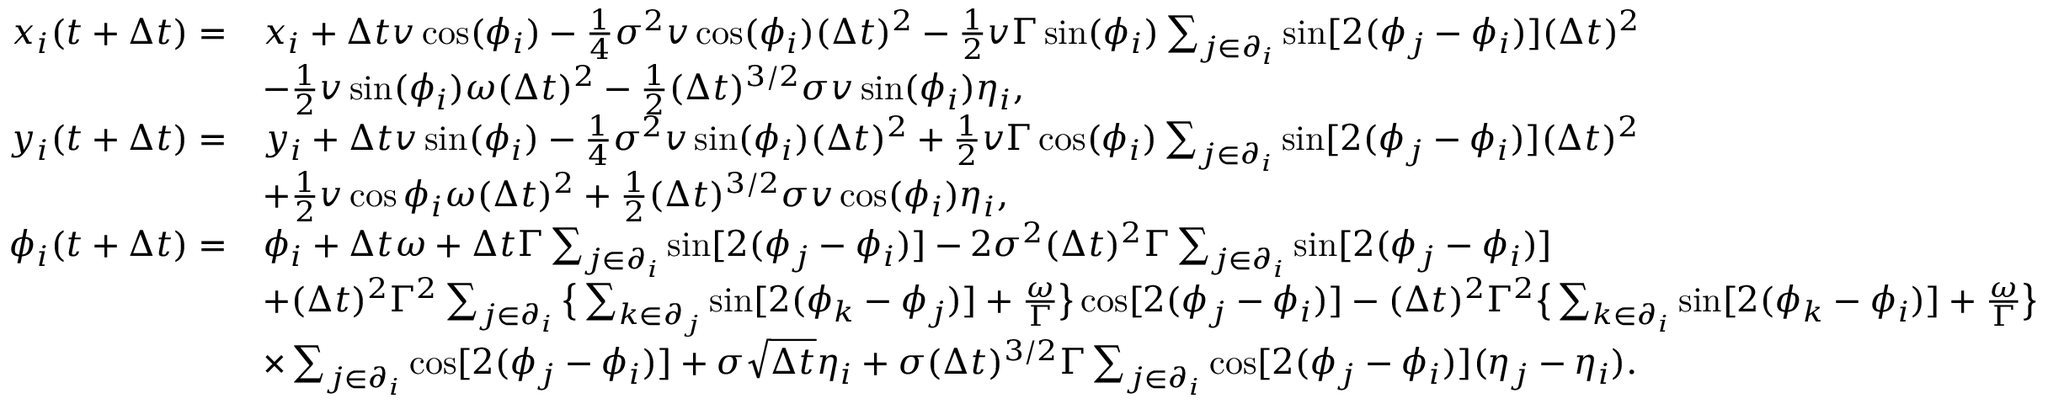<formula> <loc_0><loc_0><loc_500><loc_500>\begin{array} { r l } { x _ { i } ( t + \Delta t ) = } & { x _ { i } + \Delta t v \cos ( \phi _ { i } ) - \frac { 1 } { 4 } \sigma ^ { 2 } v \cos ( \phi _ { i } ) ( \Delta t ) ^ { 2 } - \frac { 1 } { 2 } v \Gamma \sin ( \phi _ { i } ) \sum _ { j \in \partial _ { i } } \sin [ 2 ( \phi _ { j } - \phi _ { i } ) ] ( \Delta t ) ^ { 2 } } \\ & { - \frac { 1 } { 2 } v \sin ( \phi _ { i } ) \omega ( \Delta t ) ^ { 2 } - \frac { 1 } { 2 } ( \Delta t ) ^ { 3 / 2 } \sigma v \sin ( \phi _ { i } ) \eta _ { i } , } \\ { y _ { i } ( t + \Delta t ) = } & { y _ { i } + \Delta t v \sin ( \phi _ { i } ) - \frac { 1 } { 4 } \sigma ^ { 2 } v \sin ( \phi _ { i } ) ( \Delta t ) ^ { 2 } + \frac { 1 } { 2 } v \Gamma \cos ( \phi _ { i } ) \sum _ { j \in \partial _ { i } } \sin [ 2 ( \phi _ { j } - \phi _ { i } ) ] ( \Delta t ) ^ { 2 } } \\ & { + \frac { 1 } { 2 } v \cos { \phi _ { i } } \omega ( \Delta t ) ^ { 2 } + \frac { 1 } { 2 } ( \Delta t ) ^ { 3 / 2 } \sigma v \cos ( \phi _ { i } ) \eta _ { i } , } \\ { \phi _ { i } ( t + \Delta t ) = } & { \phi _ { i } + \Delta t \omega + \Delta t \Gamma \sum _ { j \in \partial _ { i } } \sin [ 2 ( \phi _ { j } - \phi _ { i } ) ] - 2 \sigma ^ { 2 } ( \Delta t ) ^ { 2 } \Gamma \sum _ { j \in \partial _ { i } } \sin [ 2 ( \phi _ { j } - \phi _ { i } ) ] } \\ & { + ( \Delta t ) ^ { 2 } \Gamma ^ { 2 } \sum _ { j \in \partial _ { i } } \left \{ \sum _ { k \in \partial _ { j } } \sin [ 2 ( \phi _ { k } - \phi _ { j } ) ] + \frac { \omega } { \Gamma } \right \} \cos [ 2 ( \phi _ { j } - \phi _ { i } ) ] - ( \Delta t ) ^ { 2 } \Gamma ^ { 2 } \left \{ \sum _ { k \in \partial _ { i } } \sin [ 2 ( \phi _ { k } - \phi _ { i } ) ] + \frac { \omega } { \Gamma } \right \} } \\ & { \times \sum _ { j \in \partial _ { i } } \cos [ 2 ( \phi _ { j } - \phi _ { i } ) ] + \sigma \sqrt { \Delta t } \eta _ { i } + \sigma ( \Delta t ) ^ { 3 / 2 } \Gamma \sum _ { j \in \partial _ { i } } \cos [ 2 ( \phi _ { j } - \phi _ { i } ) ] ( \eta _ { j } - \eta _ { i } ) . } \end{array}</formula> 